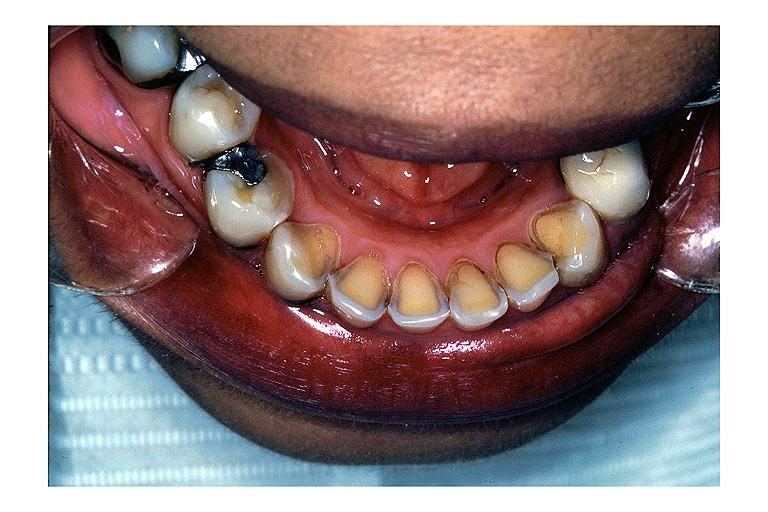does foot show erosion?
Answer the question using a single word or phrase. No 